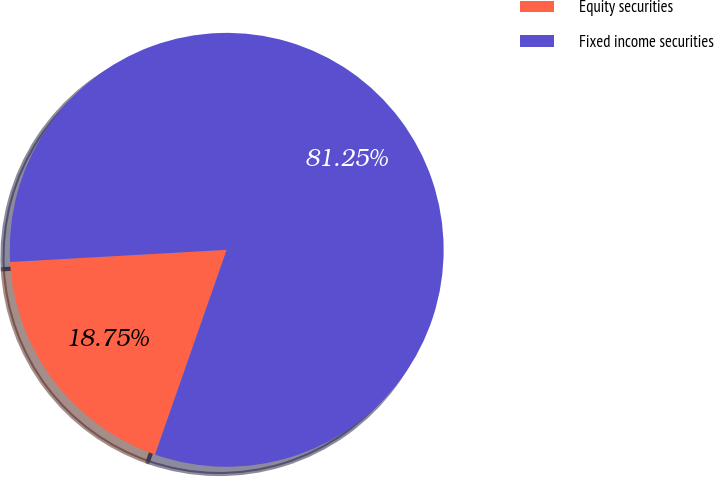Convert chart. <chart><loc_0><loc_0><loc_500><loc_500><pie_chart><fcel>Equity securities<fcel>Fixed income securities<nl><fcel>18.75%<fcel>81.25%<nl></chart> 